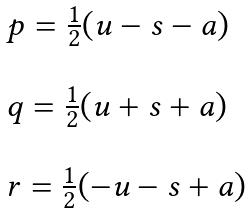Convert formula to latex. <formula><loc_0><loc_0><loc_500><loc_500>\begin{array} { l } p = \frac { 1 } { 2 } ( u - s - a ) \\ \\ q = \frac { 1 } { 2 } ( u + s + a ) \\ \\ r = \frac { 1 } { 2 } ( - u - s + a ) \end{array}</formula> 